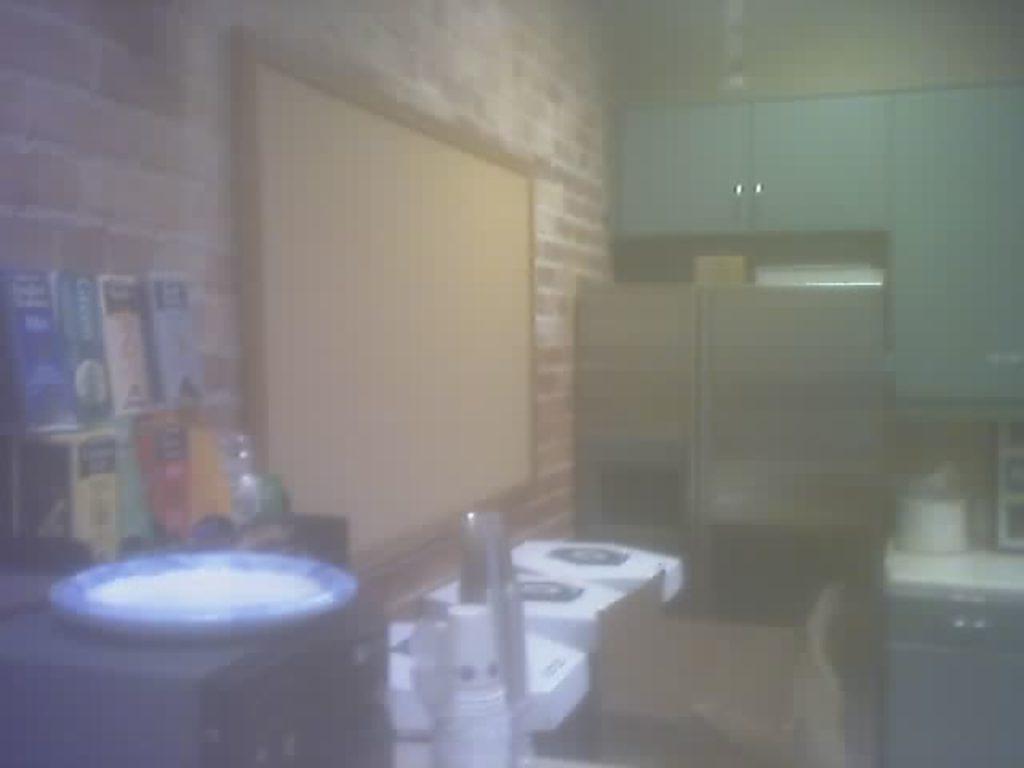In one or two sentences, can you explain what this image depicts? There is a plate on an object. On the right side, there is a vessel on the table. In the middle, there are glasses arranged. In the background, there are books arranged, there is a board on the brick, cupboards attached to the wall and there are other objects. 